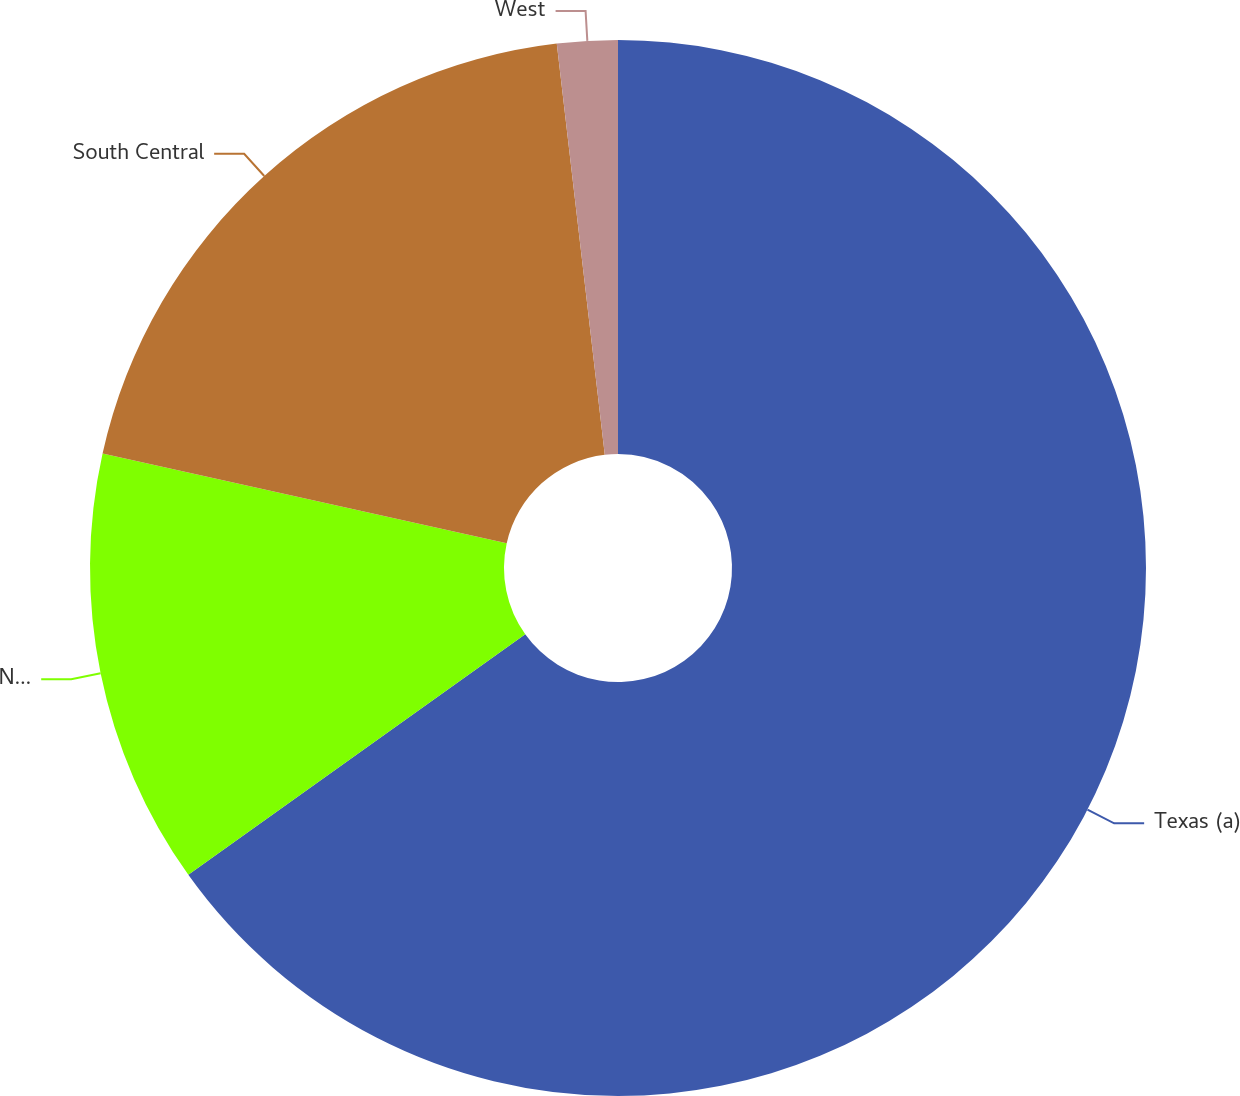<chart> <loc_0><loc_0><loc_500><loc_500><pie_chart><fcel>Texas (a)<fcel>Northeast (b)<fcel>South Central<fcel>West<nl><fcel>65.13%<fcel>13.35%<fcel>19.67%<fcel>1.85%<nl></chart> 